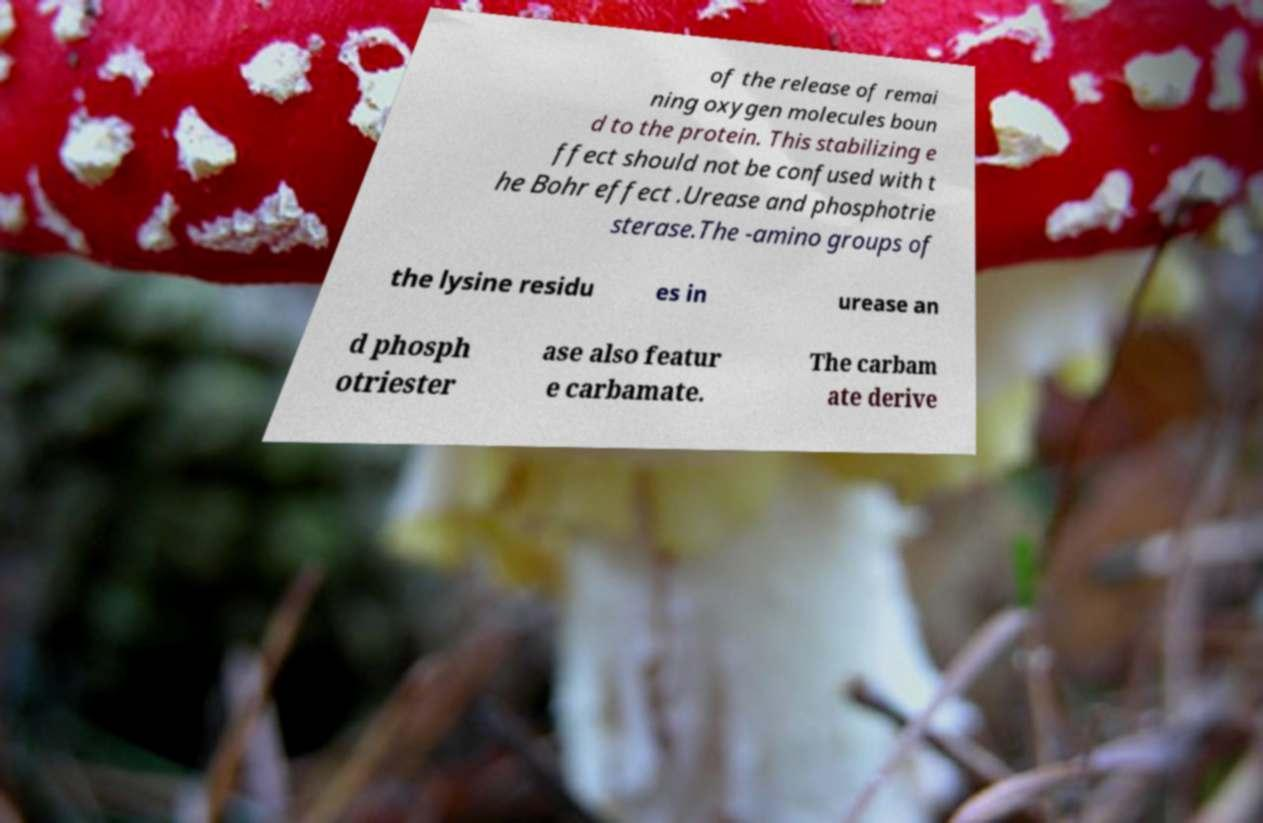Please read and relay the text visible in this image. What does it say? of the release of remai ning oxygen molecules boun d to the protein. This stabilizing e ffect should not be confused with t he Bohr effect .Urease and phosphotrie sterase.The -amino groups of the lysine residu es in urease an d phosph otriester ase also featur e carbamate. The carbam ate derive 